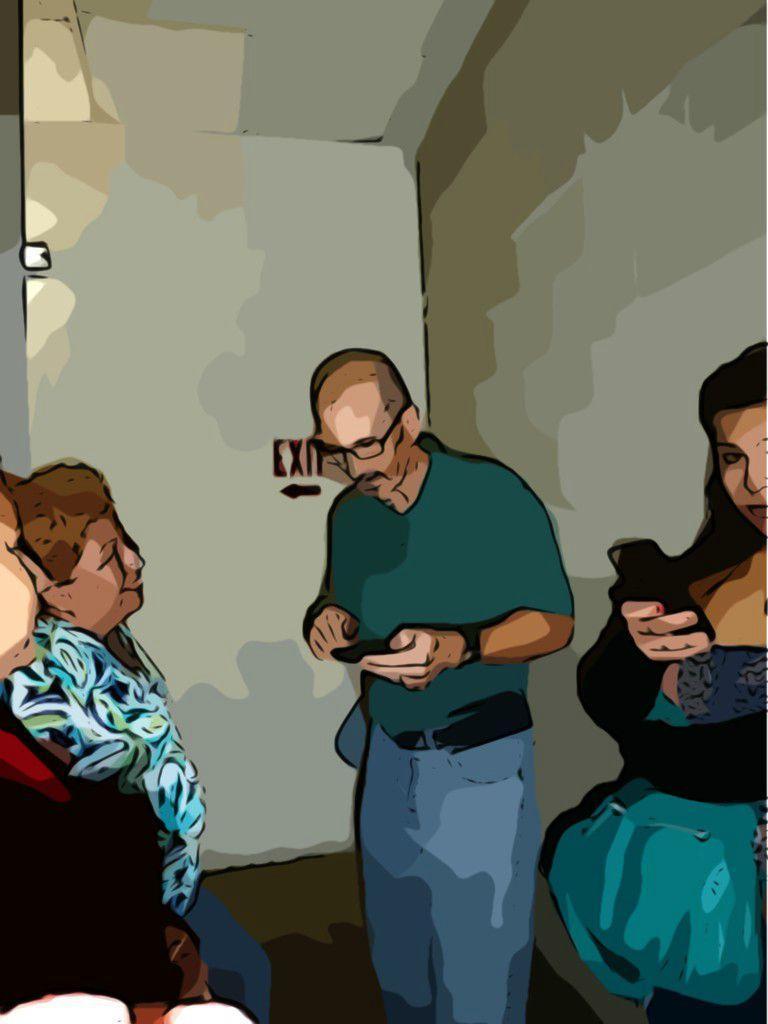How would you summarize this image in a sentence or two? In this image we can see a painting of persons, a man holding an object and a woman holding a cellphone and a exit board in the background. 